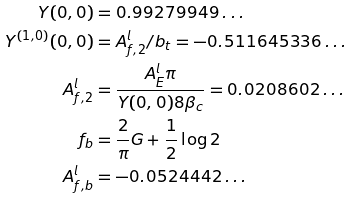<formula> <loc_0><loc_0><loc_500><loc_500>Y ( 0 , 0 ) & = 0 . 9 9 2 7 9 9 4 9 \dots \\ Y ^ { ( 1 , 0 ) } ( 0 , 0 ) & = A ^ { l } _ { f , 2 } / b _ { t } = - 0 . 5 1 1 6 4 5 3 3 6 \dots \\ A ^ { l } _ { f , 2 } & = \frac { A ^ { l } _ { E } \pi } { Y ( 0 , 0 ) 8 \beta _ { c } } = 0 . 0 2 0 8 6 0 2 \dots \\ f _ { b } & = \frac { 2 } { \pi } G + \frac { 1 } { 2 } \log 2 \\ A ^ { l } _ { f , b } & = - 0 . 0 5 2 4 4 4 2 \dots</formula> 